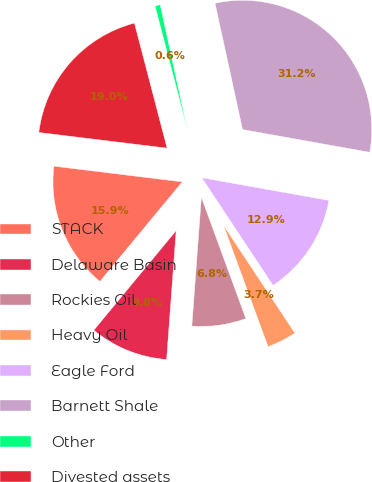<chart> <loc_0><loc_0><loc_500><loc_500><pie_chart><fcel>STACK<fcel>Delaware Basin<fcel>Rockies Oil<fcel>Heavy Oil<fcel>Eagle Ford<fcel>Barnett Shale<fcel>Other<fcel>Divested assets<nl><fcel>15.94%<fcel>9.82%<fcel>6.77%<fcel>3.71%<fcel>12.88%<fcel>31.23%<fcel>0.65%<fcel>19.0%<nl></chart> 